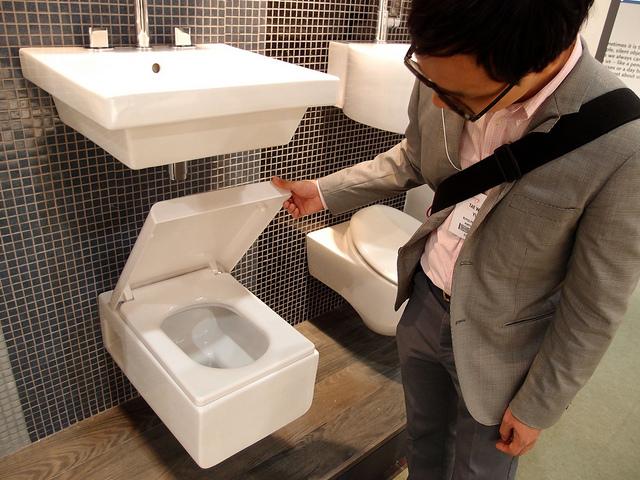Where is the sink?
Keep it brief. Above toilet. What shape is the toilet?
Be succinct. Square. Is the toilet clean?
Give a very brief answer. Yes. 